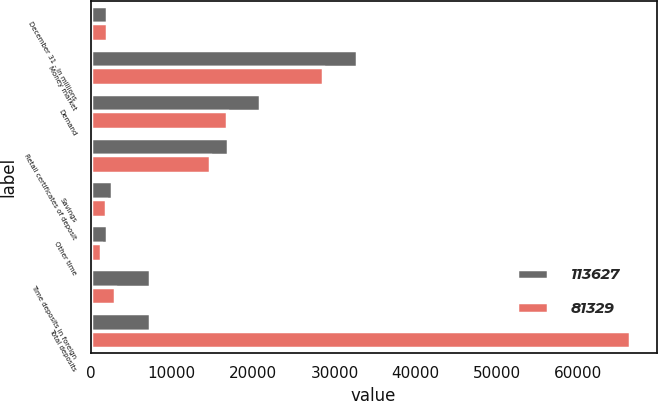<chart> <loc_0><loc_0><loc_500><loc_500><stacked_bar_chart><ecel><fcel>December 31 - in millions<fcel>Money market<fcel>Demand<fcel>Retail certificates of deposit<fcel>Savings<fcel>Other time<fcel>Time deposits in foreign<fcel>Total deposits<nl><fcel>113627<fcel>2007<fcel>32785<fcel>20861<fcel>16939<fcel>2648<fcel>2088<fcel>7375<fcel>7375<nl><fcel>81329<fcel>2006<fcel>28580<fcel>16833<fcel>14725<fcel>1864<fcel>1326<fcel>2973<fcel>66301<nl></chart> 